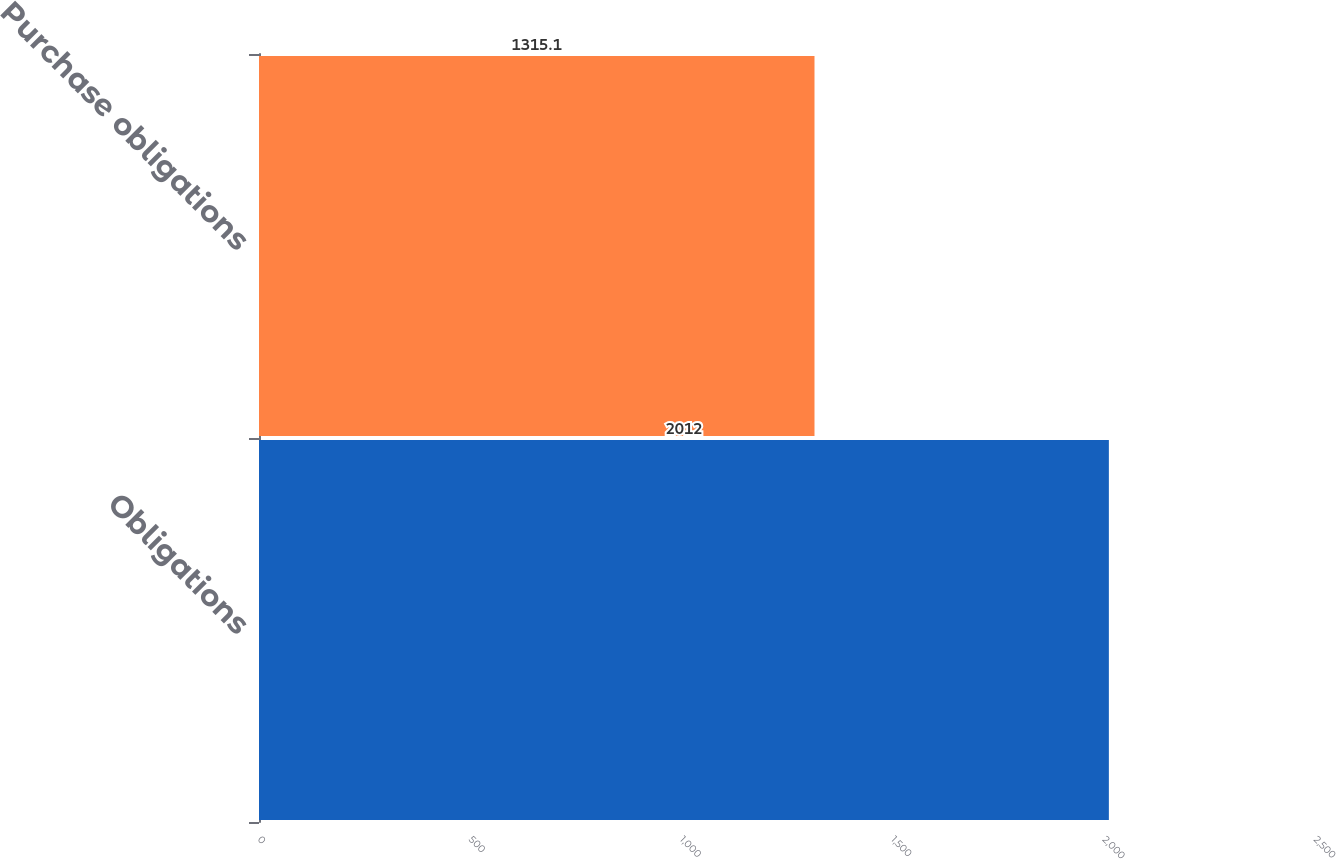Convert chart to OTSL. <chart><loc_0><loc_0><loc_500><loc_500><bar_chart><fcel>Obligations<fcel>Purchase obligations<nl><fcel>2012<fcel>1315.1<nl></chart> 